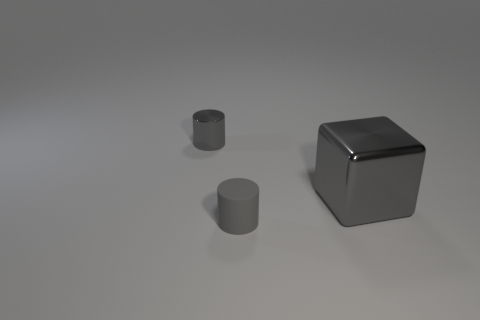What shapes are present in the image? The image displays three geometric shapes: a cube and two cylinders. The shapes have a reflective surface, suggesting they could be made of a metallic material. 